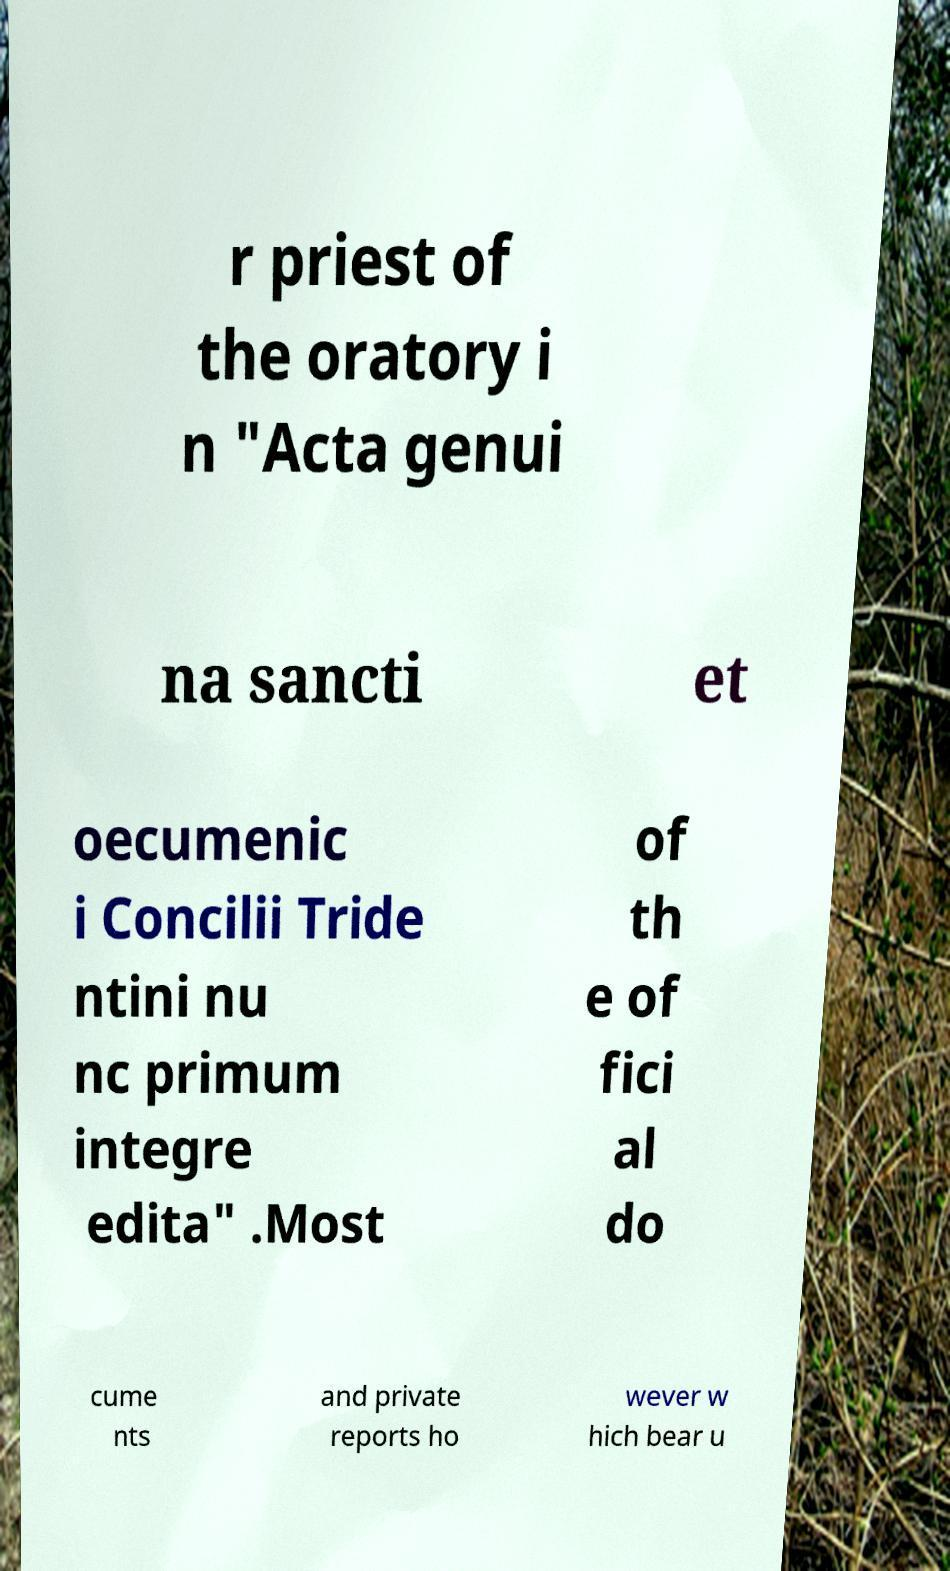Can you accurately transcribe the text from the provided image for me? r priest of the oratory i n "Acta genui na sancti et oecumenic i Concilii Tride ntini nu nc primum integre edita" .Most of th e of fici al do cume nts and private reports ho wever w hich bear u 